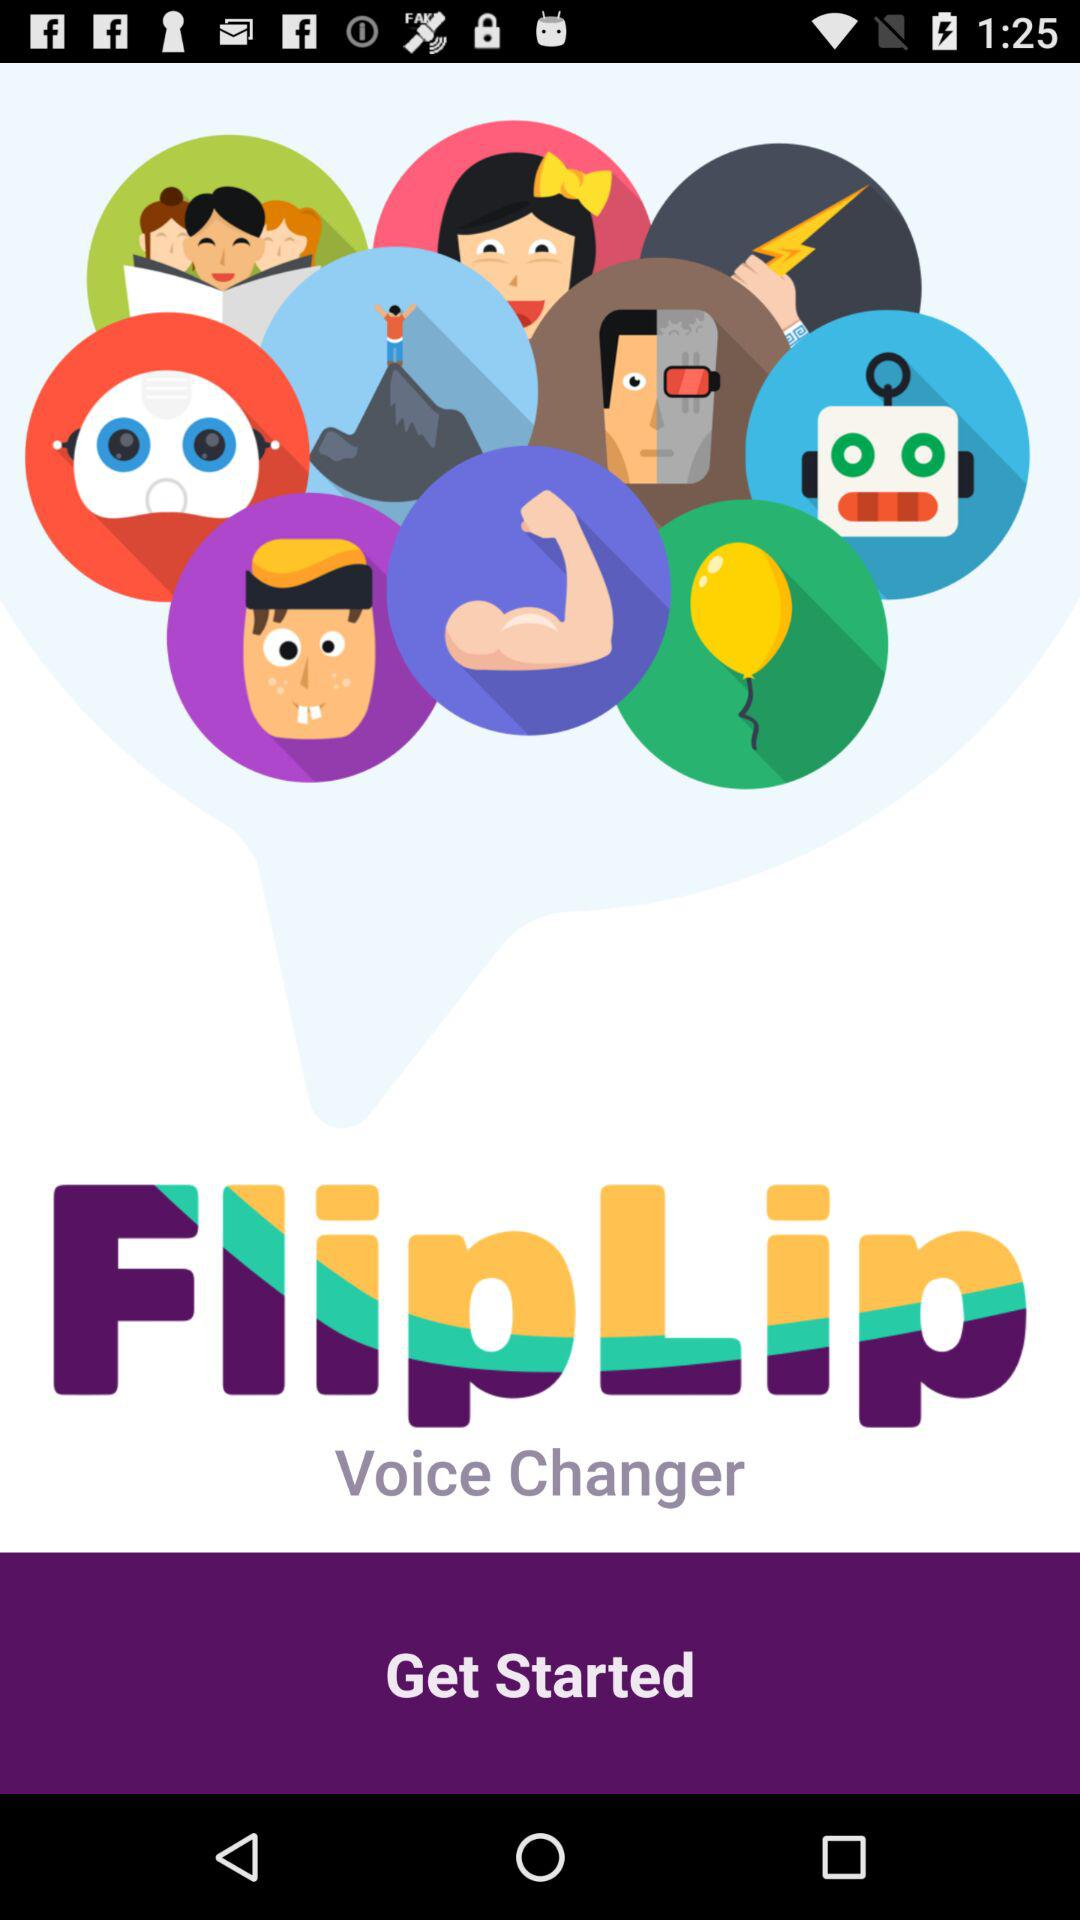What is the name of the application? The name of the application is "FlipLip Voice Changer". 